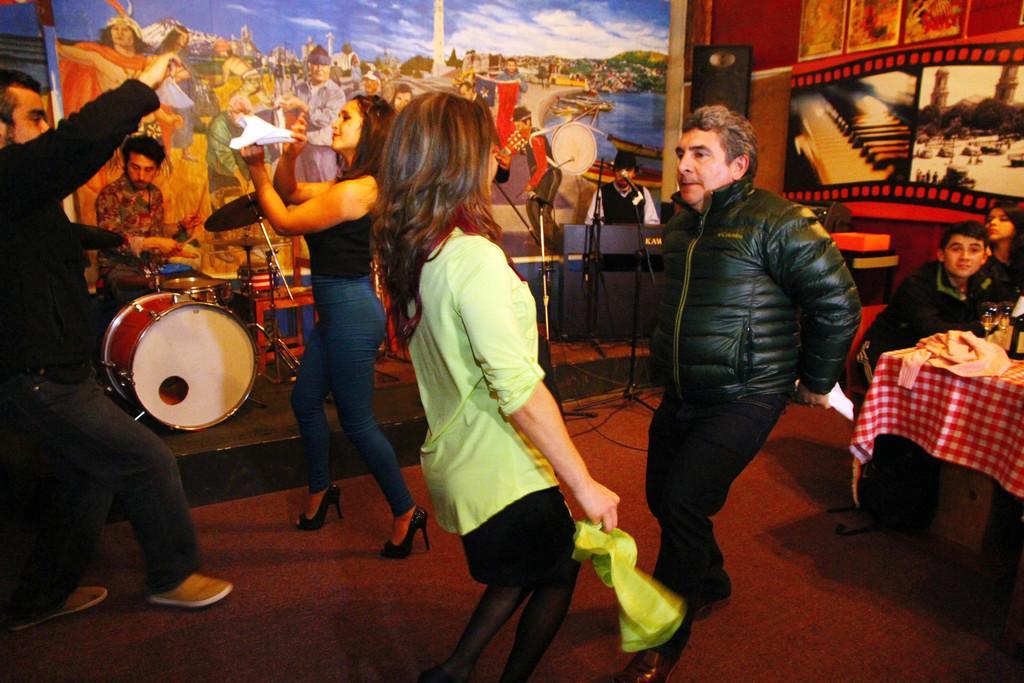In one or two sentences, can you explain what this image depicts? The image is inside the room. In the image there are four people dancing, on right side there are two people sitting on chair in front of a table. On table we can see a cloth,wine glass,bottle on left side there is a man playing his musical instruments, in background we can see painting,speaker and a man playing musical instrument,microphone. 